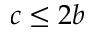<formula> <loc_0><loc_0><loc_500><loc_500>c \leq 2 b</formula> 